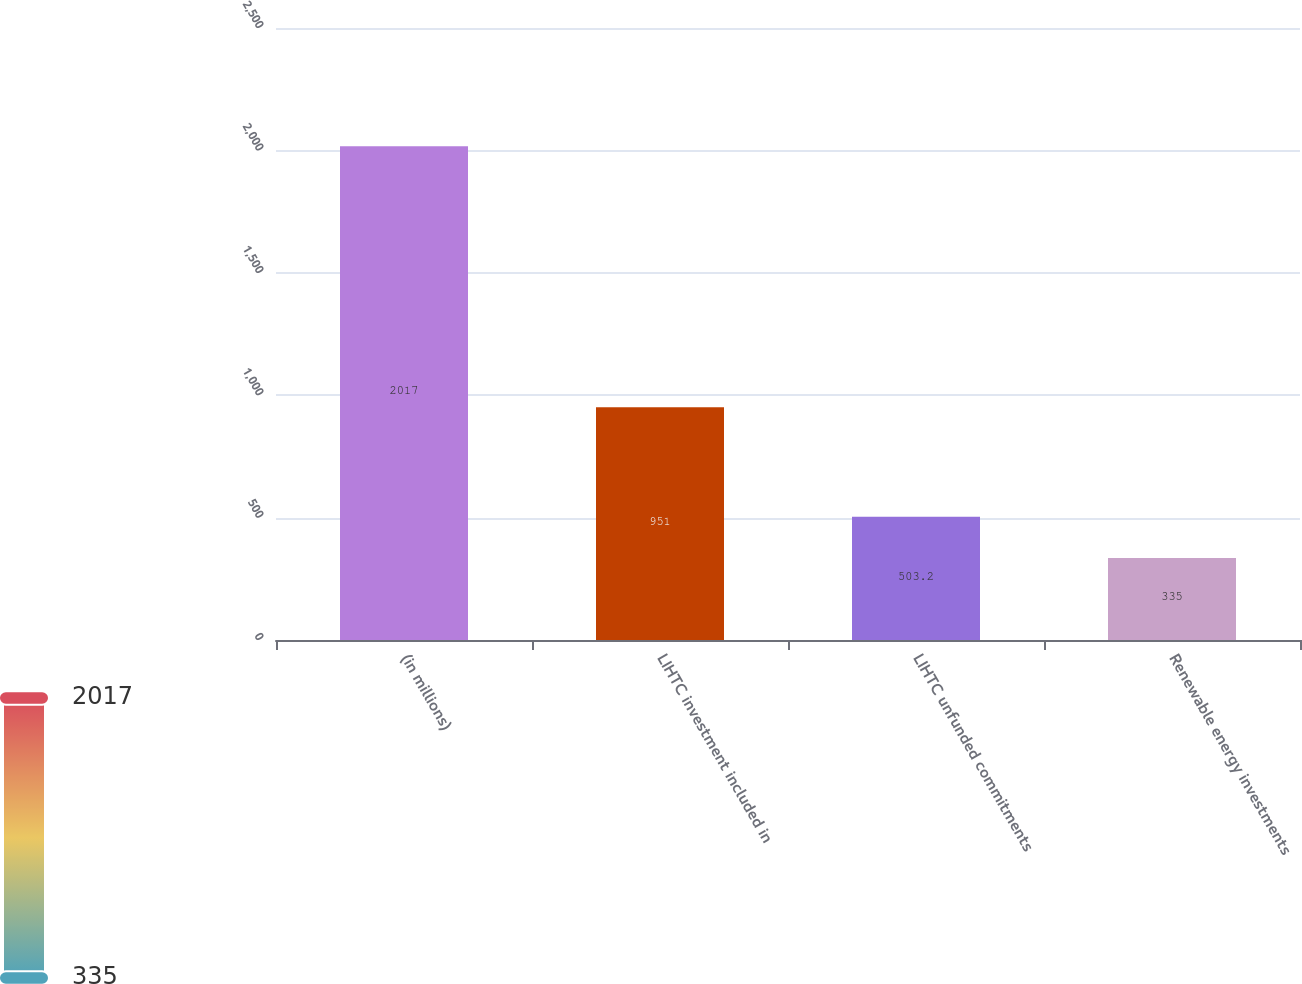Convert chart. <chart><loc_0><loc_0><loc_500><loc_500><bar_chart><fcel>(in millions)<fcel>LIHTC investment included in<fcel>LIHTC unfunded commitments<fcel>Renewable energy investments<nl><fcel>2017<fcel>951<fcel>503.2<fcel>335<nl></chart> 